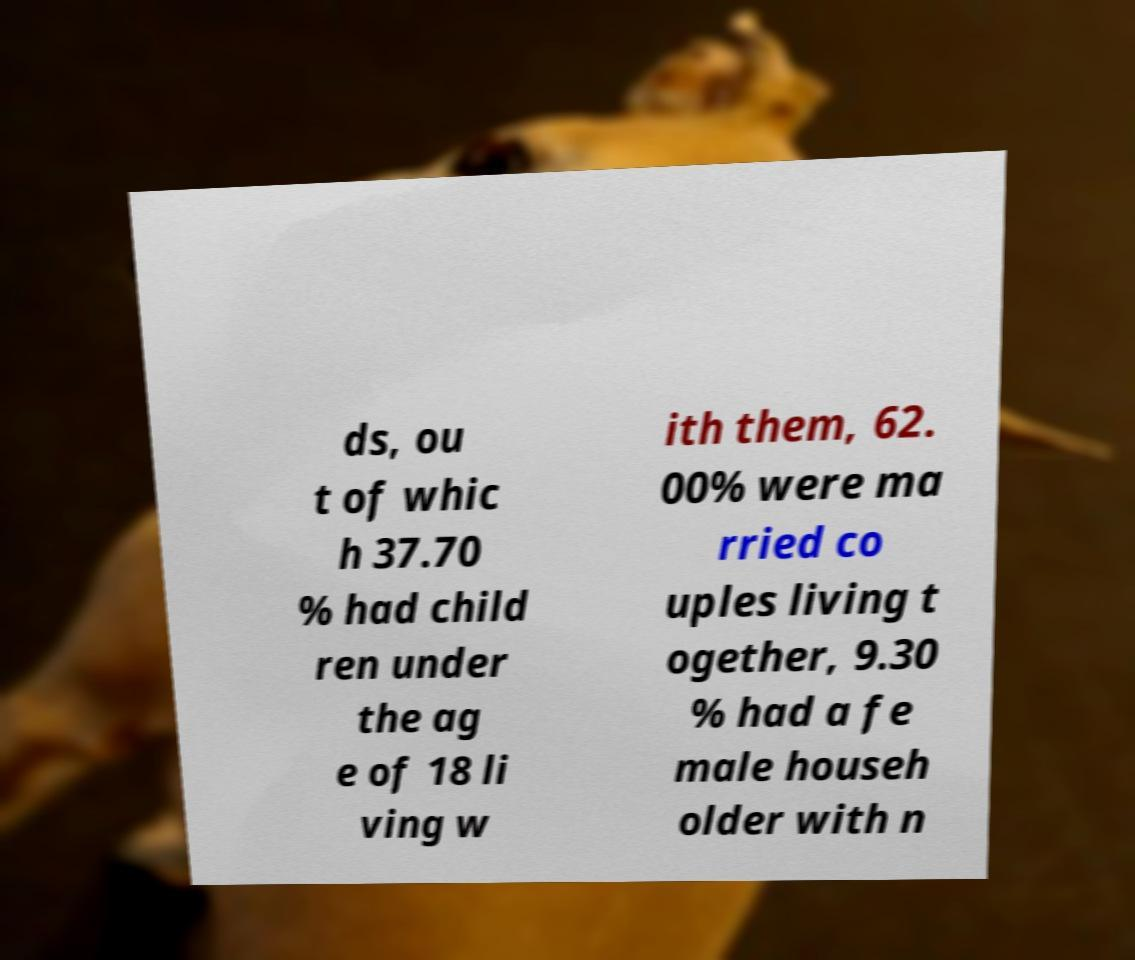Can you read and provide the text displayed in the image?This photo seems to have some interesting text. Can you extract and type it out for me? ds, ou t of whic h 37.70 % had child ren under the ag e of 18 li ving w ith them, 62. 00% were ma rried co uples living t ogether, 9.30 % had a fe male househ older with n 